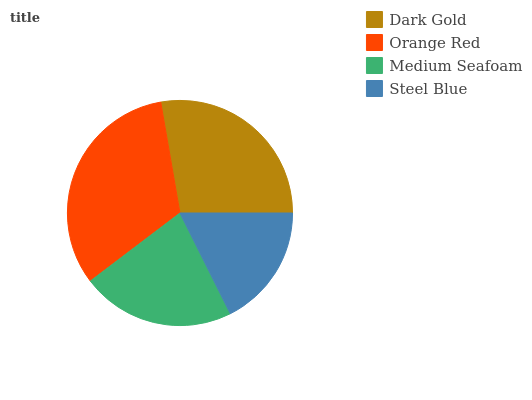Is Steel Blue the minimum?
Answer yes or no. Yes. Is Orange Red the maximum?
Answer yes or no. Yes. Is Medium Seafoam the minimum?
Answer yes or no. No. Is Medium Seafoam the maximum?
Answer yes or no. No. Is Orange Red greater than Medium Seafoam?
Answer yes or no. Yes. Is Medium Seafoam less than Orange Red?
Answer yes or no. Yes. Is Medium Seafoam greater than Orange Red?
Answer yes or no. No. Is Orange Red less than Medium Seafoam?
Answer yes or no. No. Is Dark Gold the high median?
Answer yes or no. Yes. Is Medium Seafoam the low median?
Answer yes or no. Yes. Is Medium Seafoam the high median?
Answer yes or no. No. Is Orange Red the low median?
Answer yes or no. No. 